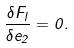Convert formula to latex. <formula><loc_0><loc_0><loc_500><loc_500>\frac { \delta F _ { l } } { \delta e _ { 2 } } = 0 .</formula> 